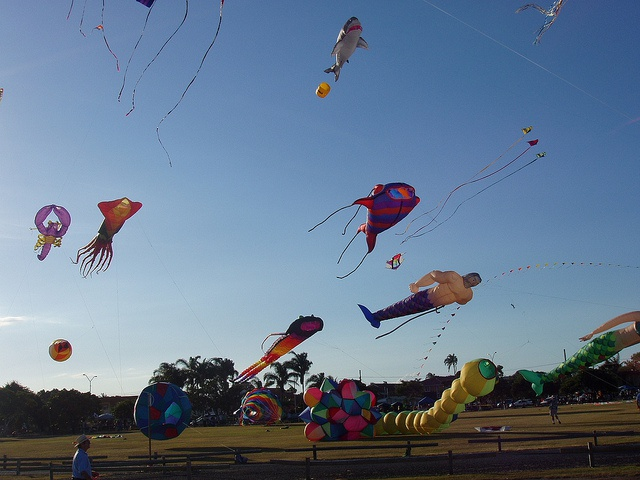Describe the objects in this image and their specific colors. I can see kite in gray, black, and darkgray tones, kite in gray, black, maroon, olive, and navy tones, kite in gray, black, brown, and navy tones, kite in gray, maroon, navy, black, and purple tones, and kite in gray, maroon, black, brown, and darkgray tones in this image. 